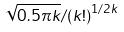Convert formula to latex. <formula><loc_0><loc_0><loc_500><loc_500>\sqrt { 0 . 5 \pi k } / { ( k ! ) } ^ { 1 / 2 k }</formula> 